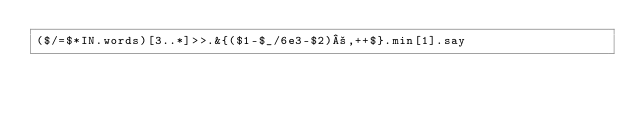Convert code to text. <code><loc_0><loc_0><loc_500><loc_500><_Perl_>($/=$*IN.words)[3..*]>>.&{($1-$_/6e3-$2)²,++$}.min[1].say</code> 